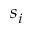<formula> <loc_0><loc_0><loc_500><loc_500>s _ { i }</formula> 